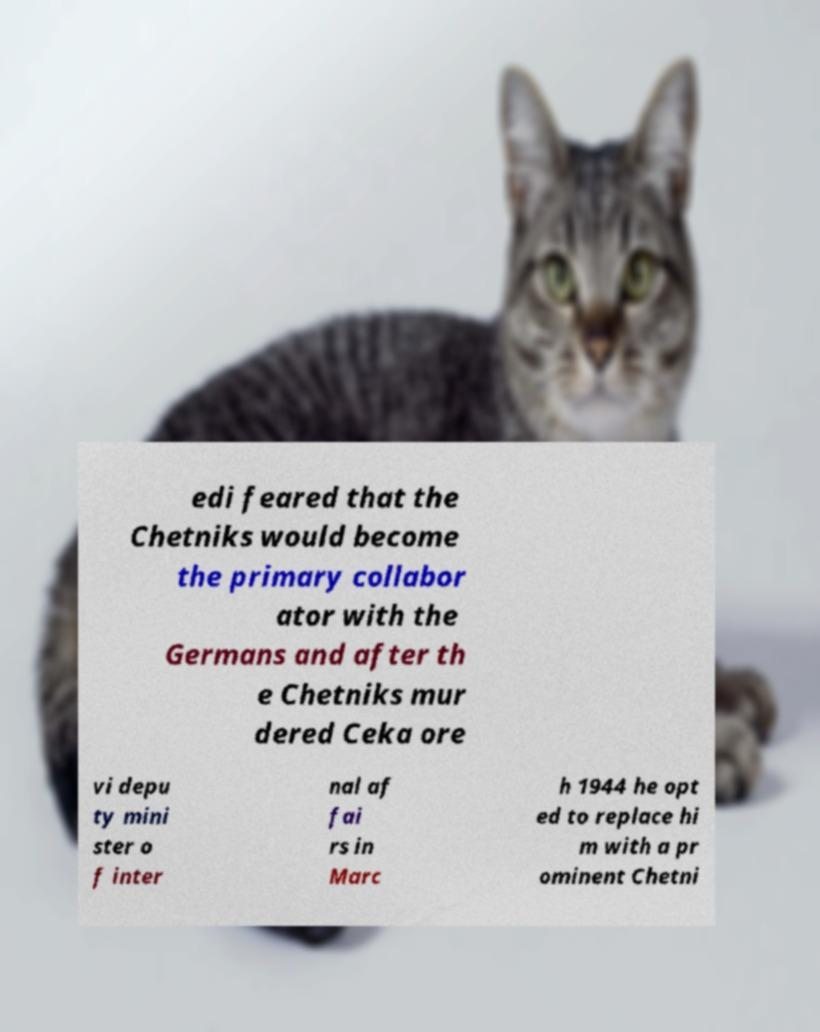Could you assist in decoding the text presented in this image and type it out clearly? edi feared that the Chetniks would become the primary collabor ator with the Germans and after th e Chetniks mur dered Ceka ore vi depu ty mini ster o f inter nal af fai rs in Marc h 1944 he opt ed to replace hi m with a pr ominent Chetni 